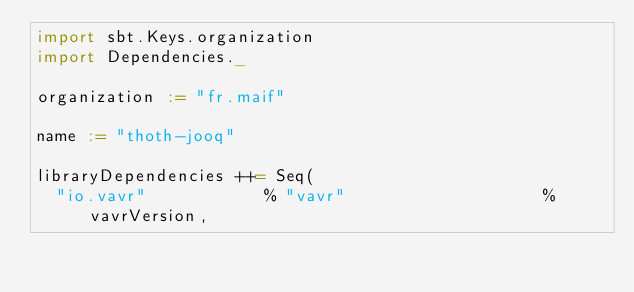Convert code to text. <code><loc_0><loc_0><loc_500><loc_500><_Scala_>import sbt.Keys.organization
import Dependencies._

organization := "fr.maif"

name := "thoth-jooq"

libraryDependencies ++= Seq(
  "io.vavr"            % "vavr"                    % vavrVersion,</code> 